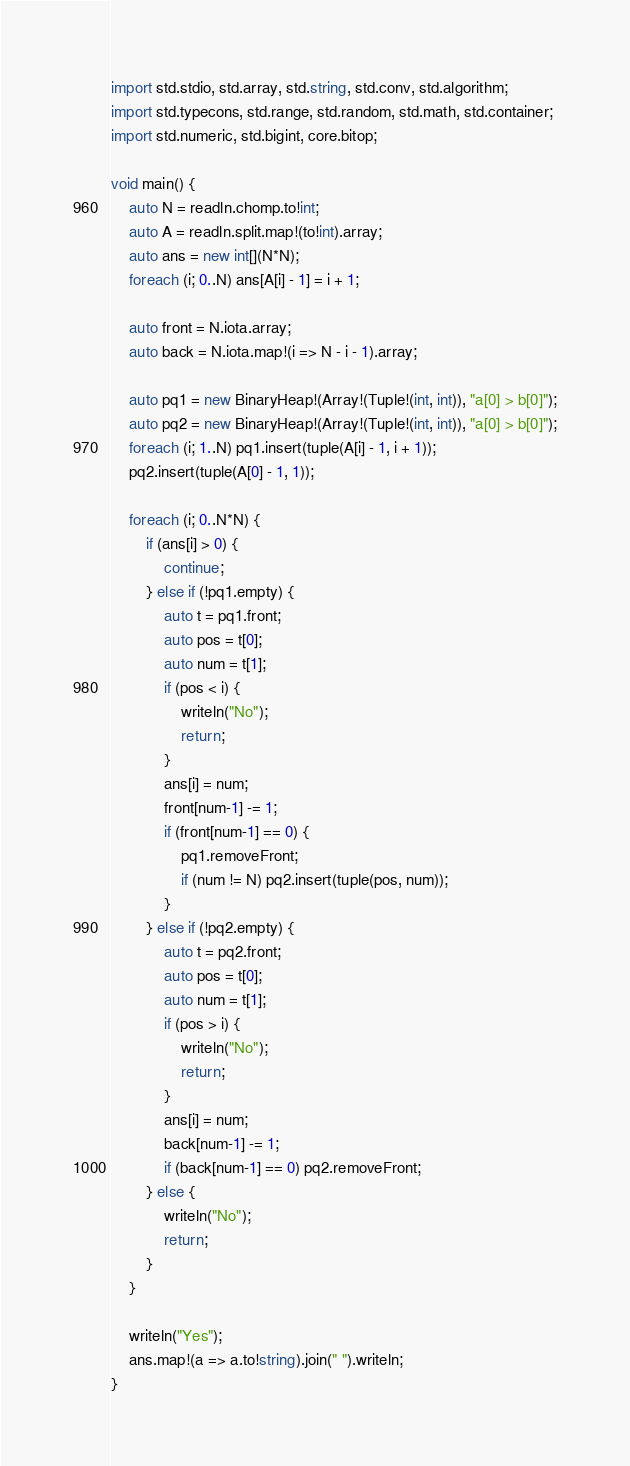Convert code to text. <code><loc_0><loc_0><loc_500><loc_500><_D_>import std.stdio, std.array, std.string, std.conv, std.algorithm;
import std.typecons, std.range, std.random, std.math, std.container;
import std.numeric, std.bigint, core.bitop;

void main() {
    auto N = readln.chomp.to!int;
    auto A = readln.split.map!(to!int).array;
    auto ans = new int[](N*N);
    foreach (i; 0..N) ans[A[i] - 1] = i + 1;
    
    auto front = N.iota.array;
    auto back = N.iota.map!(i => N - i - 1).array;

    auto pq1 = new BinaryHeap!(Array!(Tuple!(int, int)), "a[0] > b[0]");
    auto pq2 = new BinaryHeap!(Array!(Tuple!(int, int)), "a[0] > b[0]");
    foreach (i; 1..N) pq1.insert(tuple(A[i] - 1, i + 1));
    pq2.insert(tuple(A[0] - 1, 1));

    foreach (i; 0..N*N) {
        if (ans[i] > 0) {
            continue;
        } else if (!pq1.empty) {
            auto t = pq1.front;
            auto pos = t[0];
            auto num = t[1];
            if (pos < i) {
                writeln("No");
                return;
            }
            ans[i] = num;
            front[num-1] -= 1;
            if (front[num-1] == 0) {
                pq1.removeFront;
                if (num != N) pq2.insert(tuple(pos, num));
            }
        } else if (!pq2.empty) {
            auto t = pq2.front;
            auto pos = t[0];
            auto num = t[1];
            if (pos > i) {
                writeln("No");
                return;
            }
            ans[i] = num;
            back[num-1] -= 1;
            if (back[num-1] == 0) pq2.removeFront;
        } else {
            writeln("No");
            return;
        }
    }

    writeln("Yes");
    ans.map!(a => a.to!string).join(" ").writeln;
}
</code> 